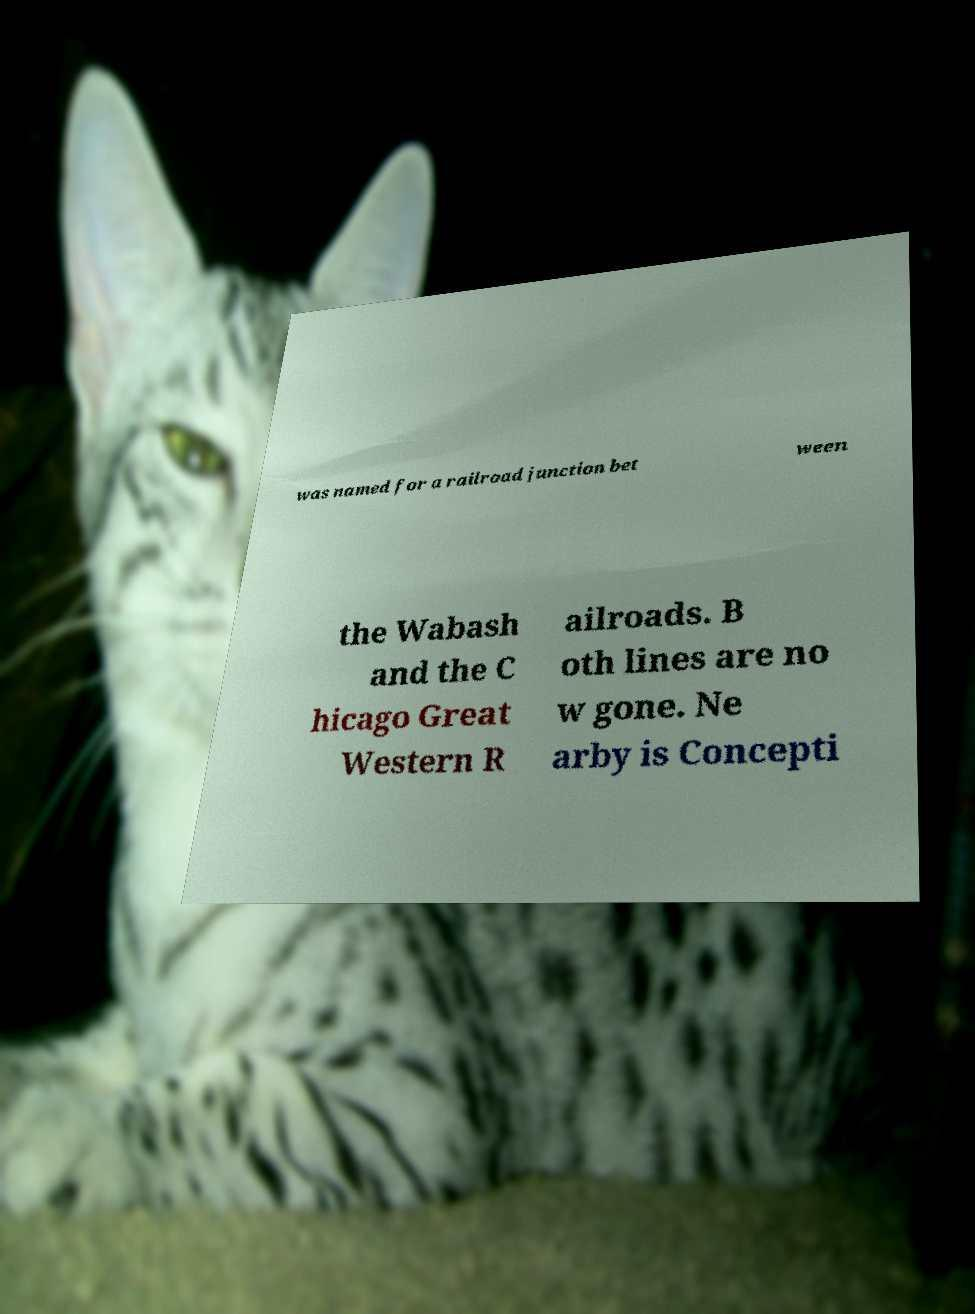What messages or text are displayed in this image? I need them in a readable, typed format. was named for a railroad junction bet ween the Wabash and the C hicago Great Western R ailroads. B oth lines are no w gone. Ne arby is Concepti 